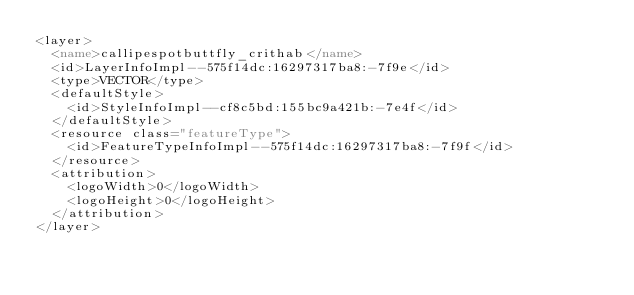<code> <loc_0><loc_0><loc_500><loc_500><_XML_><layer>
  <name>callipespotbuttfly_crithab</name>
  <id>LayerInfoImpl--575f14dc:16297317ba8:-7f9e</id>
  <type>VECTOR</type>
  <defaultStyle>
    <id>StyleInfoImpl--cf8c5bd:155bc9a421b:-7e4f</id>
  </defaultStyle>
  <resource class="featureType">
    <id>FeatureTypeInfoImpl--575f14dc:16297317ba8:-7f9f</id>
  </resource>
  <attribution>
    <logoWidth>0</logoWidth>
    <logoHeight>0</logoHeight>
  </attribution>
</layer></code> 